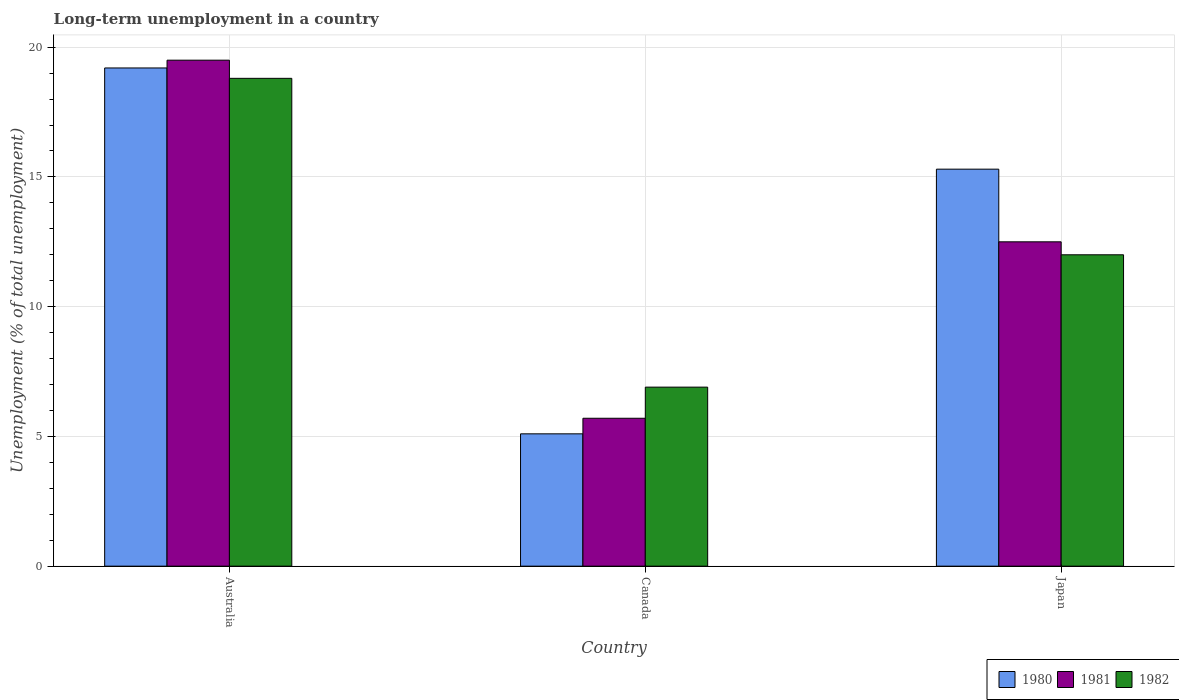Are the number of bars per tick equal to the number of legend labels?
Provide a succinct answer. Yes. How many bars are there on the 1st tick from the left?
Give a very brief answer. 3. How many bars are there on the 3rd tick from the right?
Your answer should be compact. 3. What is the label of the 1st group of bars from the left?
Your answer should be compact. Australia. What is the percentage of long-term unemployed population in 1981 in Canada?
Offer a very short reply. 5.7. Across all countries, what is the minimum percentage of long-term unemployed population in 1982?
Your answer should be compact. 6.9. What is the total percentage of long-term unemployed population in 1981 in the graph?
Provide a succinct answer. 37.7. What is the difference between the percentage of long-term unemployed population in 1981 in Australia and that in Canada?
Give a very brief answer. 13.8. What is the average percentage of long-term unemployed population in 1981 per country?
Keep it short and to the point. 12.57. What is the difference between the percentage of long-term unemployed population of/in 1982 and percentage of long-term unemployed population of/in 1981 in Australia?
Keep it short and to the point. -0.7. In how many countries, is the percentage of long-term unemployed population in 1980 greater than 6 %?
Your answer should be compact. 2. What is the ratio of the percentage of long-term unemployed population in 1982 in Canada to that in Japan?
Give a very brief answer. 0.58. Is the percentage of long-term unemployed population in 1980 in Canada less than that in Japan?
Provide a short and direct response. Yes. What is the difference between the highest and the lowest percentage of long-term unemployed population in 1980?
Your answer should be compact. 14.1. In how many countries, is the percentage of long-term unemployed population in 1982 greater than the average percentage of long-term unemployed population in 1982 taken over all countries?
Give a very brief answer. 1. Is the sum of the percentage of long-term unemployed population in 1981 in Canada and Japan greater than the maximum percentage of long-term unemployed population in 1980 across all countries?
Provide a short and direct response. No. What does the 2nd bar from the left in Canada represents?
Keep it short and to the point. 1981. What is the difference between two consecutive major ticks on the Y-axis?
Your response must be concise. 5. How are the legend labels stacked?
Provide a short and direct response. Horizontal. What is the title of the graph?
Provide a short and direct response. Long-term unemployment in a country. What is the label or title of the X-axis?
Offer a terse response. Country. What is the label or title of the Y-axis?
Keep it short and to the point. Unemployment (% of total unemployment). What is the Unemployment (% of total unemployment) in 1980 in Australia?
Your response must be concise. 19.2. What is the Unemployment (% of total unemployment) in 1981 in Australia?
Your response must be concise. 19.5. What is the Unemployment (% of total unemployment) in 1982 in Australia?
Provide a short and direct response. 18.8. What is the Unemployment (% of total unemployment) in 1980 in Canada?
Provide a succinct answer. 5.1. What is the Unemployment (% of total unemployment) of 1981 in Canada?
Offer a terse response. 5.7. What is the Unemployment (% of total unemployment) in 1982 in Canada?
Ensure brevity in your answer.  6.9. What is the Unemployment (% of total unemployment) in 1980 in Japan?
Your answer should be compact. 15.3. What is the Unemployment (% of total unemployment) in 1982 in Japan?
Provide a succinct answer. 12. Across all countries, what is the maximum Unemployment (% of total unemployment) of 1980?
Provide a succinct answer. 19.2. Across all countries, what is the maximum Unemployment (% of total unemployment) in 1982?
Keep it short and to the point. 18.8. Across all countries, what is the minimum Unemployment (% of total unemployment) of 1980?
Give a very brief answer. 5.1. Across all countries, what is the minimum Unemployment (% of total unemployment) in 1981?
Provide a short and direct response. 5.7. Across all countries, what is the minimum Unemployment (% of total unemployment) in 1982?
Your response must be concise. 6.9. What is the total Unemployment (% of total unemployment) of 1980 in the graph?
Make the answer very short. 39.6. What is the total Unemployment (% of total unemployment) in 1981 in the graph?
Provide a short and direct response. 37.7. What is the total Unemployment (% of total unemployment) of 1982 in the graph?
Ensure brevity in your answer.  37.7. What is the difference between the Unemployment (% of total unemployment) of 1980 in Australia and that in Canada?
Your response must be concise. 14.1. What is the difference between the Unemployment (% of total unemployment) of 1981 in Australia and that in Canada?
Give a very brief answer. 13.8. What is the difference between the Unemployment (% of total unemployment) in 1980 in Australia and that in Japan?
Give a very brief answer. 3.9. What is the difference between the Unemployment (% of total unemployment) of 1981 in Australia and that in Japan?
Keep it short and to the point. 7. What is the difference between the Unemployment (% of total unemployment) in 1982 in Australia and that in Japan?
Provide a short and direct response. 6.8. What is the difference between the Unemployment (% of total unemployment) of 1980 in Canada and that in Japan?
Provide a succinct answer. -10.2. What is the difference between the Unemployment (% of total unemployment) of 1981 in Canada and that in Japan?
Give a very brief answer. -6.8. What is the difference between the Unemployment (% of total unemployment) in 1982 in Canada and that in Japan?
Your response must be concise. -5.1. What is the difference between the Unemployment (% of total unemployment) in 1981 in Australia and the Unemployment (% of total unemployment) in 1982 in Canada?
Your answer should be very brief. 12.6. What is the difference between the Unemployment (% of total unemployment) of 1980 in Australia and the Unemployment (% of total unemployment) of 1982 in Japan?
Your answer should be compact. 7.2. What is the difference between the Unemployment (% of total unemployment) in 1980 in Canada and the Unemployment (% of total unemployment) in 1982 in Japan?
Your answer should be very brief. -6.9. What is the difference between the Unemployment (% of total unemployment) of 1981 in Canada and the Unemployment (% of total unemployment) of 1982 in Japan?
Provide a short and direct response. -6.3. What is the average Unemployment (% of total unemployment) in 1980 per country?
Your answer should be compact. 13.2. What is the average Unemployment (% of total unemployment) of 1981 per country?
Provide a succinct answer. 12.57. What is the average Unemployment (% of total unemployment) in 1982 per country?
Give a very brief answer. 12.57. What is the difference between the Unemployment (% of total unemployment) in 1980 and Unemployment (% of total unemployment) in 1981 in Australia?
Your answer should be compact. -0.3. What is the difference between the Unemployment (% of total unemployment) in 1980 and Unemployment (% of total unemployment) in 1981 in Japan?
Provide a short and direct response. 2.8. What is the difference between the Unemployment (% of total unemployment) of 1981 and Unemployment (% of total unemployment) of 1982 in Japan?
Your response must be concise. 0.5. What is the ratio of the Unemployment (% of total unemployment) in 1980 in Australia to that in Canada?
Your response must be concise. 3.76. What is the ratio of the Unemployment (% of total unemployment) in 1981 in Australia to that in Canada?
Offer a terse response. 3.42. What is the ratio of the Unemployment (% of total unemployment) in 1982 in Australia to that in Canada?
Make the answer very short. 2.72. What is the ratio of the Unemployment (% of total unemployment) of 1980 in Australia to that in Japan?
Your answer should be compact. 1.25. What is the ratio of the Unemployment (% of total unemployment) in 1981 in Australia to that in Japan?
Offer a very short reply. 1.56. What is the ratio of the Unemployment (% of total unemployment) of 1982 in Australia to that in Japan?
Provide a succinct answer. 1.57. What is the ratio of the Unemployment (% of total unemployment) of 1981 in Canada to that in Japan?
Offer a terse response. 0.46. What is the ratio of the Unemployment (% of total unemployment) in 1982 in Canada to that in Japan?
Give a very brief answer. 0.57. What is the difference between the highest and the second highest Unemployment (% of total unemployment) in 1981?
Make the answer very short. 7. What is the difference between the highest and the second highest Unemployment (% of total unemployment) in 1982?
Ensure brevity in your answer.  6.8. What is the difference between the highest and the lowest Unemployment (% of total unemployment) of 1980?
Keep it short and to the point. 14.1. What is the difference between the highest and the lowest Unemployment (% of total unemployment) in 1981?
Your answer should be very brief. 13.8. 